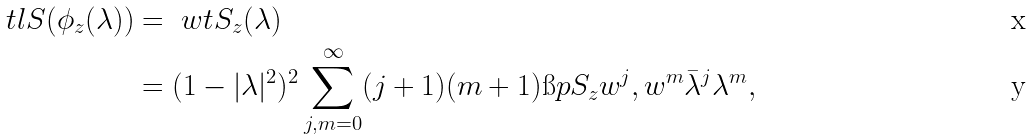<formula> <loc_0><loc_0><loc_500><loc_500>\ t l { S } ( \phi _ { z } ( \lambda ) ) & = \ w t { S _ { z } } ( \lambda ) \\ & = ( 1 - | \lambda | ^ { 2 } ) ^ { 2 } \sum _ { j , m = 0 } ^ { \infty } ( j + 1 ) ( m + 1 ) \i p { S _ { z } w ^ { j } , w ^ { m } } \bar { \lambda } ^ { j } \lambda ^ { m } ,</formula> 